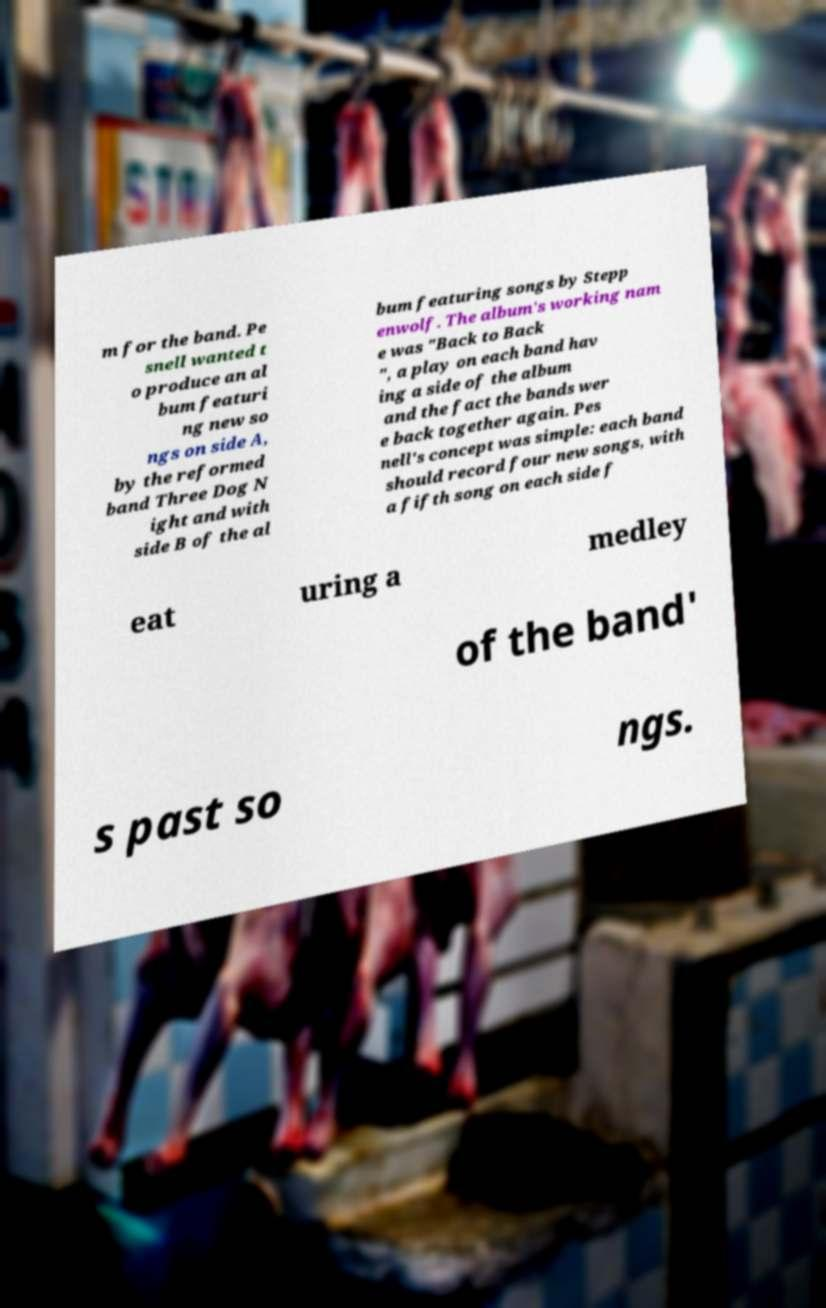What messages or text are displayed in this image? I need them in a readable, typed format. m for the band. Pe snell wanted t o produce an al bum featuri ng new so ngs on side A, by the reformed band Three Dog N ight and with side B of the al bum featuring songs by Stepp enwolf. The album's working nam e was "Back to Back ", a play on each band hav ing a side of the album and the fact the bands wer e back together again. Pes nell's concept was simple: each band should record four new songs, with a fifth song on each side f eat uring a medley of the band' s past so ngs. 